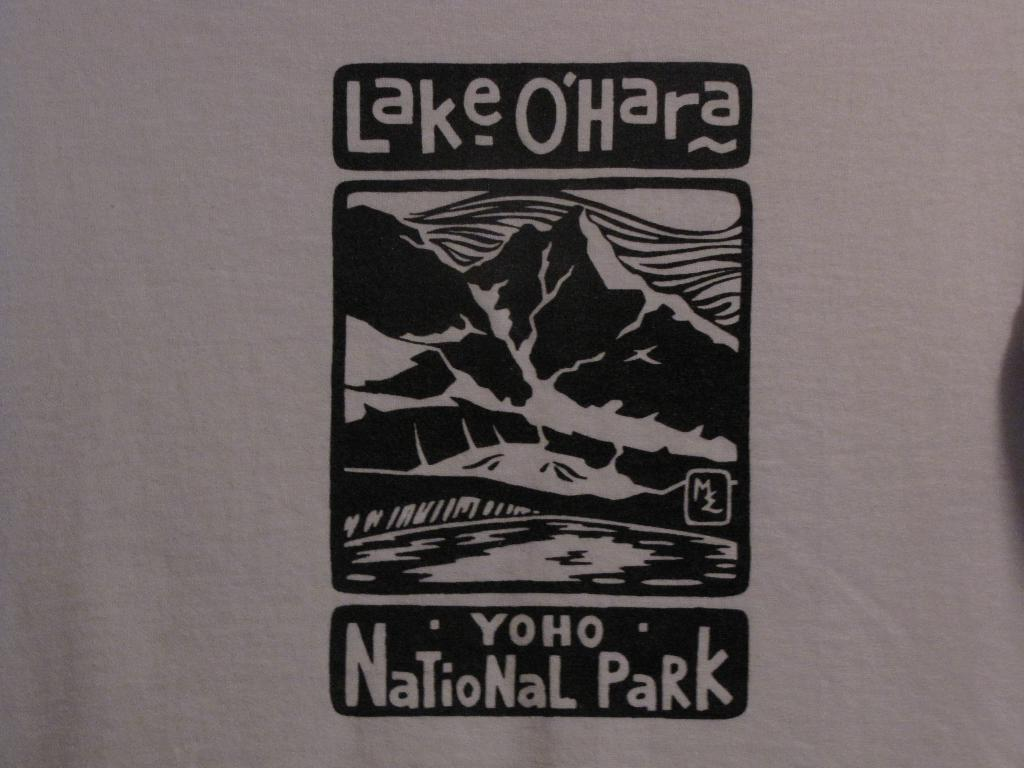What is the main subject of the image? There is an art piece in the image. Can you describe the art piece? Unfortunately, the description of the art piece is not provided in the facts. What else can be seen in the image besides the art piece? There is text on a plane surface in the image. What type of hill can be seen in the background of the image? There is no hill present in the image; it only features an art piece and text on a plane surface. How many roots are visible in the image? There are no roots visible in the image. 